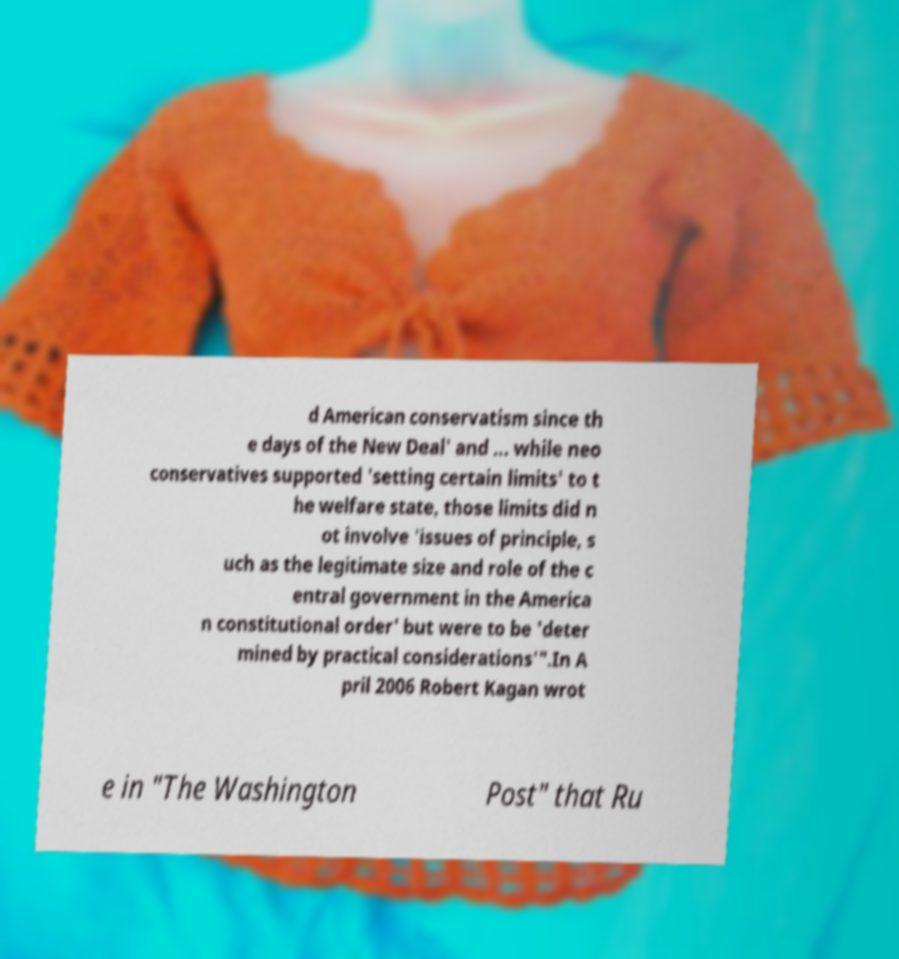Can you accurately transcribe the text from the provided image for me? d American conservatism since th e days of the New Deal' and ... while neo conservatives supported 'setting certain limits' to t he welfare state, those limits did n ot involve 'issues of principle, s uch as the legitimate size and role of the c entral government in the America n constitutional order' but were to be 'deter mined by practical considerations'".In A pril 2006 Robert Kagan wrot e in "The Washington Post" that Ru 